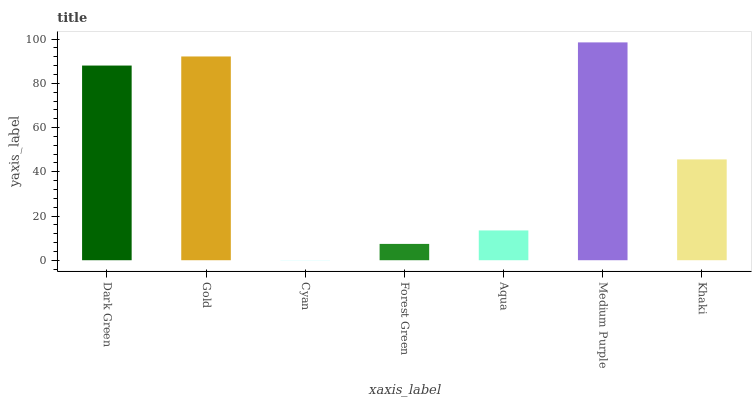Is Cyan the minimum?
Answer yes or no. Yes. Is Medium Purple the maximum?
Answer yes or no. Yes. Is Gold the minimum?
Answer yes or no. No. Is Gold the maximum?
Answer yes or no. No. Is Gold greater than Dark Green?
Answer yes or no. Yes. Is Dark Green less than Gold?
Answer yes or no. Yes. Is Dark Green greater than Gold?
Answer yes or no. No. Is Gold less than Dark Green?
Answer yes or no. No. Is Khaki the high median?
Answer yes or no. Yes. Is Khaki the low median?
Answer yes or no. Yes. Is Gold the high median?
Answer yes or no. No. Is Cyan the low median?
Answer yes or no. No. 